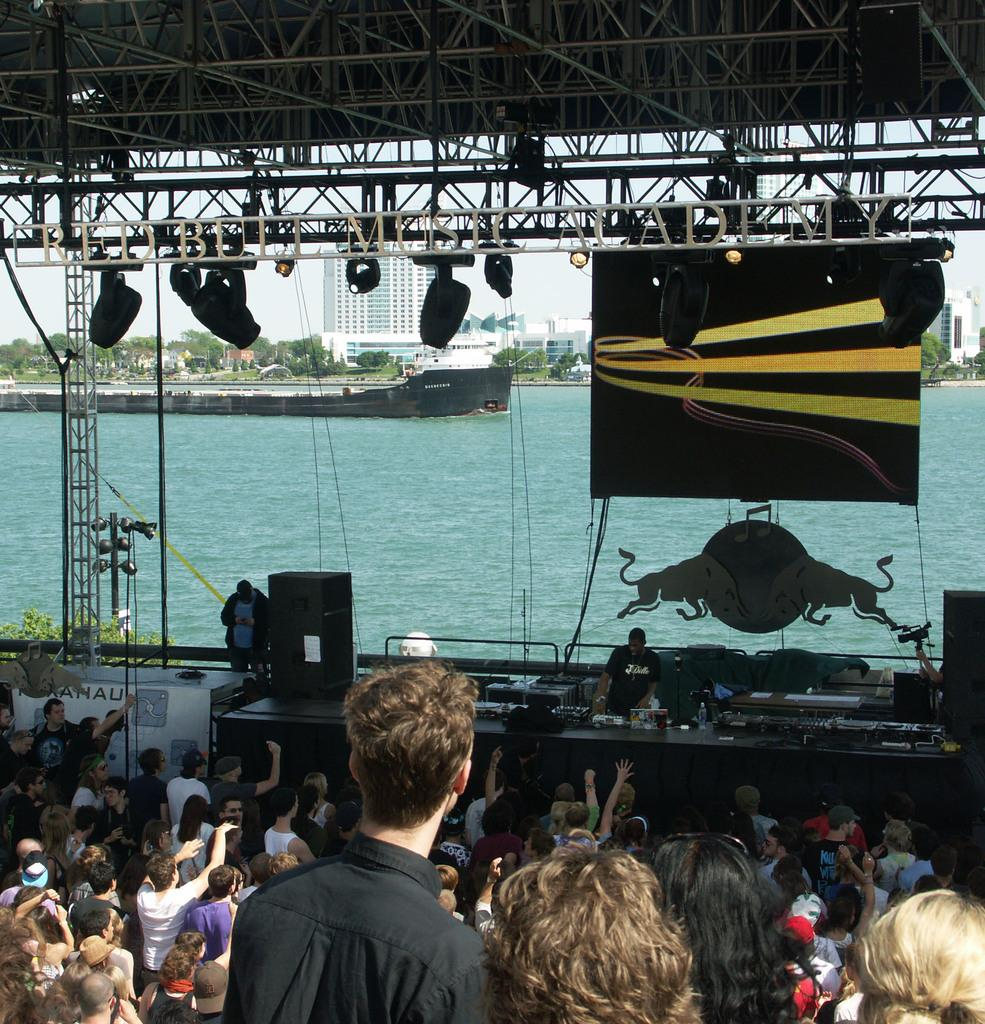How many people are in the group visible in the image? There is a group of people standing in the image, but the exact number cannot be determined from the provided facts. What is written on the banner in the image? The content of the banner cannot be determined from the provided facts. What are the speakers used for in the image? The purpose of the speakers cannot be determined from the provided facts. What type of lights are present in the image? The type of lights cannot be determined from the provided facts. What type of buildings can be seen in the image? The type of buildings cannot be determined from the provided facts. What type of trees are present in the image? The type of trees cannot be determined from the provided facts. What is the boat doing on the water in the image? The activity of the boat cannot be determined from the provided facts. What is visible in the background of the image? The sky is visible in the background of the image. What type of celery is being used as a decoration in the image? There is no celery present in the image. What type of art can be seen on the banner in the image? The content of the banner cannot be determined from the provided facts, so it is impossible to determine if there is any art present. 